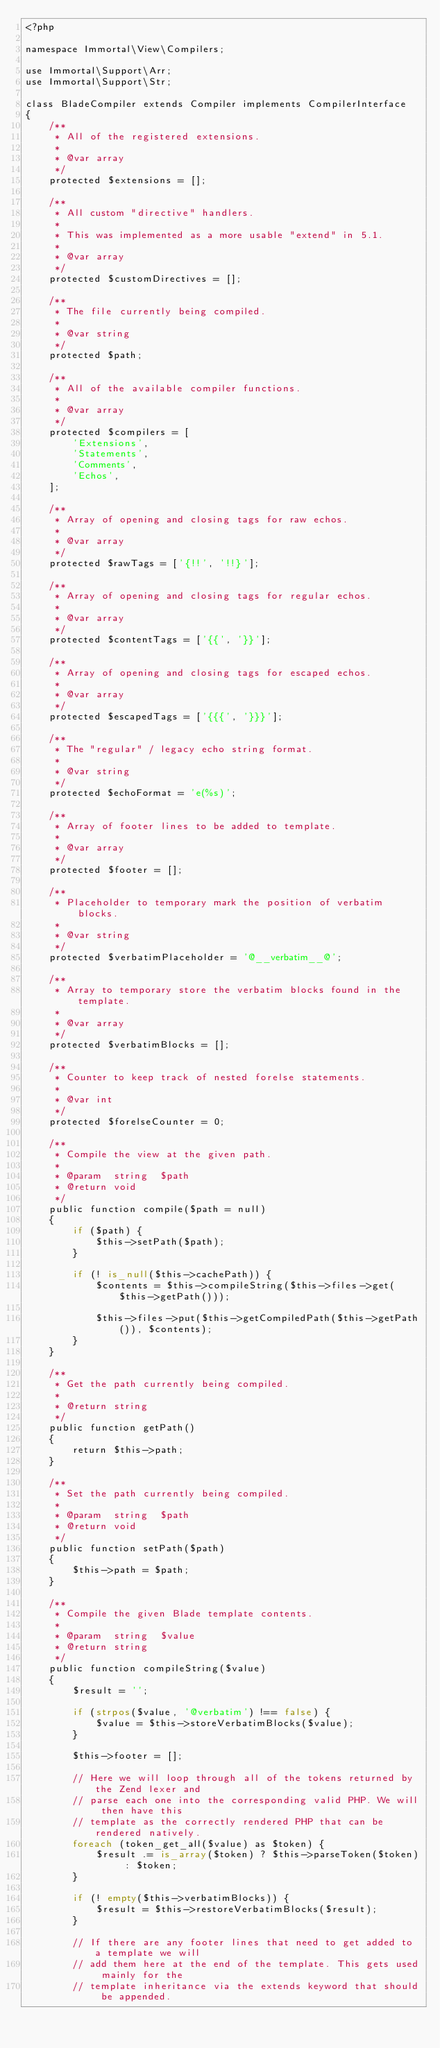Convert code to text. <code><loc_0><loc_0><loc_500><loc_500><_PHP_><?php

namespace Immortal\View\Compilers;

use Immortal\Support\Arr;
use Immortal\Support\Str;

class BladeCompiler extends Compiler implements CompilerInterface
{
    /**
     * All of the registered extensions.
     *
     * @var array
     */
    protected $extensions = [];

    /**
     * All custom "directive" handlers.
     *
     * This was implemented as a more usable "extend" in 5.1.
     *
     * @var array
     */
    protected $customDirectives = [];

    /**
     * The file currently being compiled.
     *
     * @var string
     */
    protected $path;

    /**
     * All of the available compiler functions.
     *
     * @var array
     */
    protected $compilers = [
        'Extensions',
        'Statements',
        'Comments',
        'Echos',
    ];

    /**
     * Array of opening and closing tags for raw echos.
     *
     * @var array
     */
    protected $rawTags = ['{!!', '!!}'];

    /**
     * Array of opening and closing tags for regular echos.
     *
     * @var array
     */
    protected $contentTags = ['{{', '}}'];

    /**
     * Array of opening and closing tags for escaped echos.
     *
     * @var array
     */
    protected $escapedTags = ['{{{', '}}}'];

    /**
     * The "regular" / legacy echo string format.
     *
     * @var string
     */
    protected $echoFormat = 'e(%s)';

    /**
     * Array of footer lines to be added to template.
     *
     * @var array
     */
    protected $footer = [];

    /**
     * Placeholder to temporary mark the position of verbatim blocks.
     *
     * @var string
     */
    protected $verbatimPlaceholder = '@__verbatim__@';

    /**
     * Array to temporary store the verbatim blocks found in the template.
     *
     * @var array
     */
    protected $verbatimBlocks = [];

    /**
     * Counter to keep track of nested forelse statements.
     *
     * @var int
     */
    protected $forelseCounter = 0;

    /**
     * Compile the view at the given path.
     *
     * @param  string  $path
     * @return void
     */
    public function compile($path = null)
    {
        if ($path) {
            $this->setPath($path);
        }

        if (! is_null($this->cachePath)) {
            $contents = $this->compileString($this->files->get($this->getPath()));

            $this->files->put($this->getCompiledPath($this->getPath()), $contents);
        }
    }

    /**
     * Get the path currently being compiled.
     *
     * @return string
     */
    public function getPath()
    {
        return $this->path;
    }

    /**
     * Set the path currently being compiled.
     *
     * @param  string  $path
     * @return void
     */
    public function setPath($path)
    {
        $this->path = $path;
    }

    /**
     * Compile the given Blade template contents.
     *
     * @param  string  $value
     * @return string
     */
    public function compileString($value)
    {
        $result = '';

        if (strpos($value, '@verbatim') !== false) {
            $value = $this->storeVerbatimBlocks($value);
        }

        $this->footer = [];

        // Here we will loop through all of the tokens returned by the Zend lexer and
        // parse each one into the corresponding valid PHP. We will then have this
        // template as the correctly rendered PHP that can be rendered natively.
        foreach (token_get_all($value) as $token) {
            $result .= is_array($token) ? $this->parseToken($token) : $token;
        }

        if (! empty($this->verbatimBlocks)) {
            $result = $this->restoreVerbatimBlocks($result);
        }

        // If there are any footer lines that need to get added to a template we will
        // add them here at the end of the template. This gets used mainly for the
        // template inheritance via the extends keyword that should be appended.</code> 